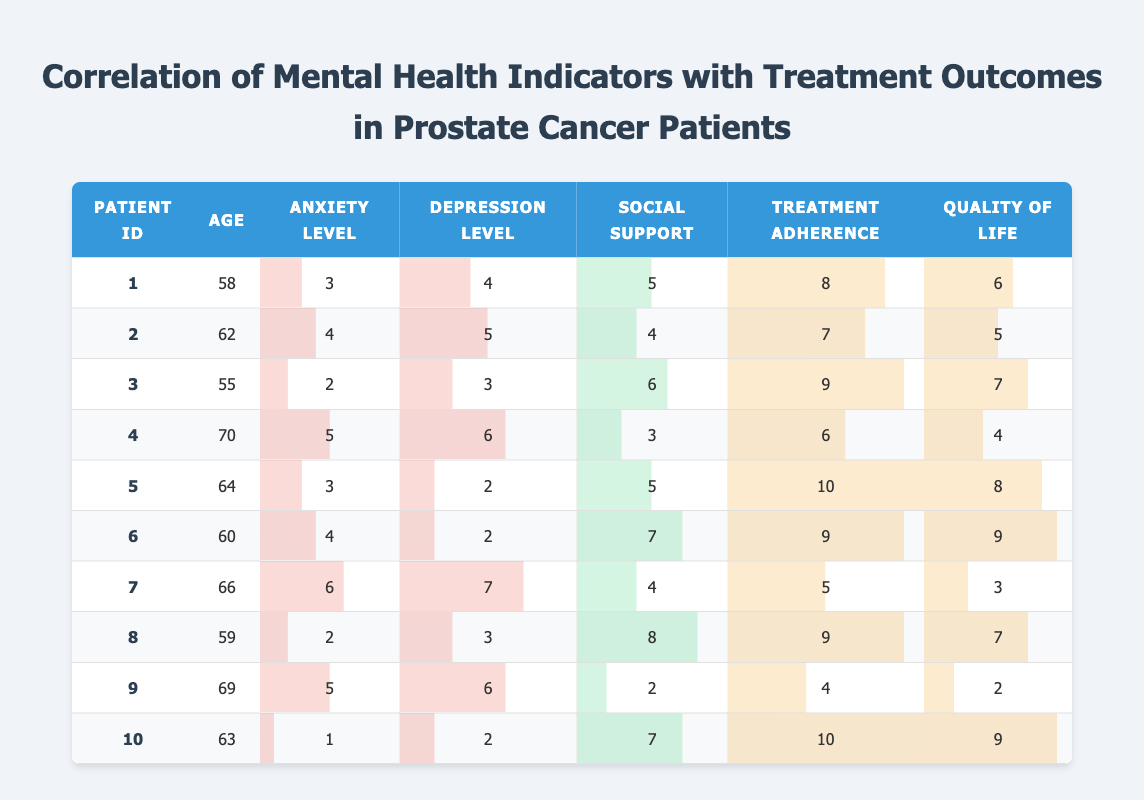What is the Anxiety Level for Patient ID 5? The table indicates that for Patient ID 5, the Anxiety Level column shows a value of 3.
Answer: 3 What is the Treatment Adherence for Patient ID 7? By looking at the row for Patient ID 7, the Treatment Adherence value is found in that row under the respective column, which is 5.
Answer: 5 What is the average Quality of Life for all patients? To find the average Quality of Life, add the values from the Quality of Life column: (6 + 5 + 7 + 4 + 8 + 9 + 3 + 7 + 2 + 9) = 60, and divide by the number of patients, which is 10. So, 60 / 10 = 6.
Answer: 6 Is there a patient with a Quality of Life lower than 3? By reviewing the Quality of Life column, the lowest value is 2, which belongs to Patient ID 9, therefore confirming that yes, at least one patient has a Quality of Life lower than 3.
Answer: Yes How many patients have a Depression Level of 2 or lower? Looking at the Depression Level column, we find only Patient ID 5 and Patient ID 6 with values of 2 and less. Therefore, 2 patients meet this criterion.
Answer: 2 What is the relationship between higher Social Support and Quality of Life? We should analyze the rows with the highest Social Support values (8 for Patient ID 8 and 7 for Patient ID 6) and their corresponding Quality of Life (both at 7 for Patient ID 8 and 9 for Patient ID 6). This suggests a positive correlation, as higher Social Support corresponds with higher Quality of Life scores.
Answer: Positive correlation What is the maximum Anxiety Level recorded among the patients? Reviewing the Anxiety Level column, the highest Anxiety Level found is 6, present in Patient ID 7.
Answer: 6 Does any patient have perfect Treatment Adherence? Investigating the Treatment Adherence column, Patient ID 5 and Patient ID 10 both have a score of 10, indicating they have perfect adherence. Thus, the answer is yes.
Answer: Yes Which patient has the highest Depression Level and what is that value? Examining the Depression Level column, Patient ID 4 and Patient ID 7 both show the highest value of 7, thus we need to state both patients show the maximum score.
Answer: Patient ID 4 and Patient ID 7, value 7 